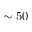Convert formula to latex. <formula><loc_0><loc_0><loc_500><loc_500>\sim 5 0</formula> 